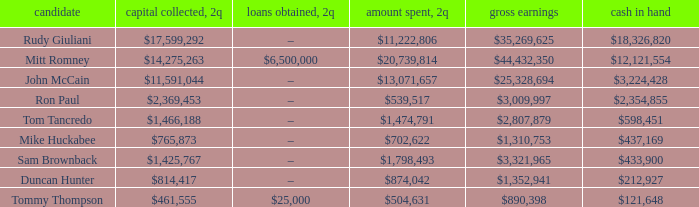Name the money raised when 2Q has money spent and 2Q is $874,042 $814,417. 